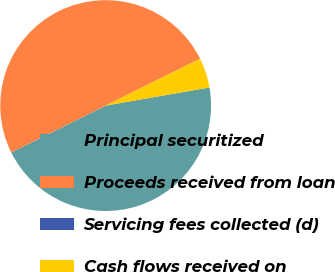Convert chart to OTSL. <chart><loc_0><loc_0><loc_500><loc_500><pie_chart><fcel>Principal securitized<fcel>Proceeds received from loan<fcel>Servicing fees collected (d)<fcel>Cash flows received on<nl><fcel>45.42%<fcel>49.99%<fcel>0.01%<fcel>4.58%<nl></chart> 